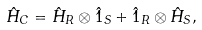Convert formula to latex. <formula><loc_0><loc_0><loc_500><loc_500>\hat { H } _ { C } = \hat { H } _ { R } \otimes \hat { 1 } _ { S } + \hat { 1 } _ { R } \otimes \hat { H } _ { S } ,</formula> 